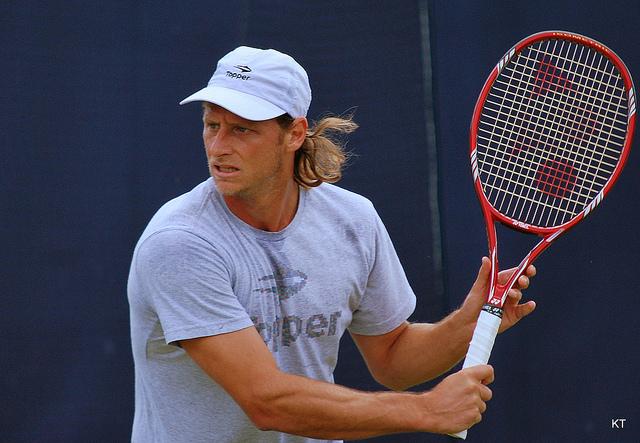What color is the racket?
Short answer required. Red. What color is his shirt?
Give a very brief answer. Gray. Is the player right-handed?
Concise answer only. No. What color is the background?
Keep it brief. Blue. Is this Roger Federer?
Give a very brief answer. No. Is this man smiling?
Give a very brief answer. No. Is the man a tennis legend?
Quick response, please. No. What kind of shirt is the man wearing?
Be succinct. T shirt. What sport is being played?
Write a very short answer. Tennis. What brand of clothing is he wearing?
Write a very short answer. Topper. What color is the handle of the racket?
Answer briefly. White. What brand is this tennis player wearing?
Answer briefly. Topper. What brand is his tennis racket?
Give a very brief answer. Nike. What brand is the racket?
Give a very brief answer. Wilson. What brand of racket is he using?
Give a very brief answer. Wilson. 